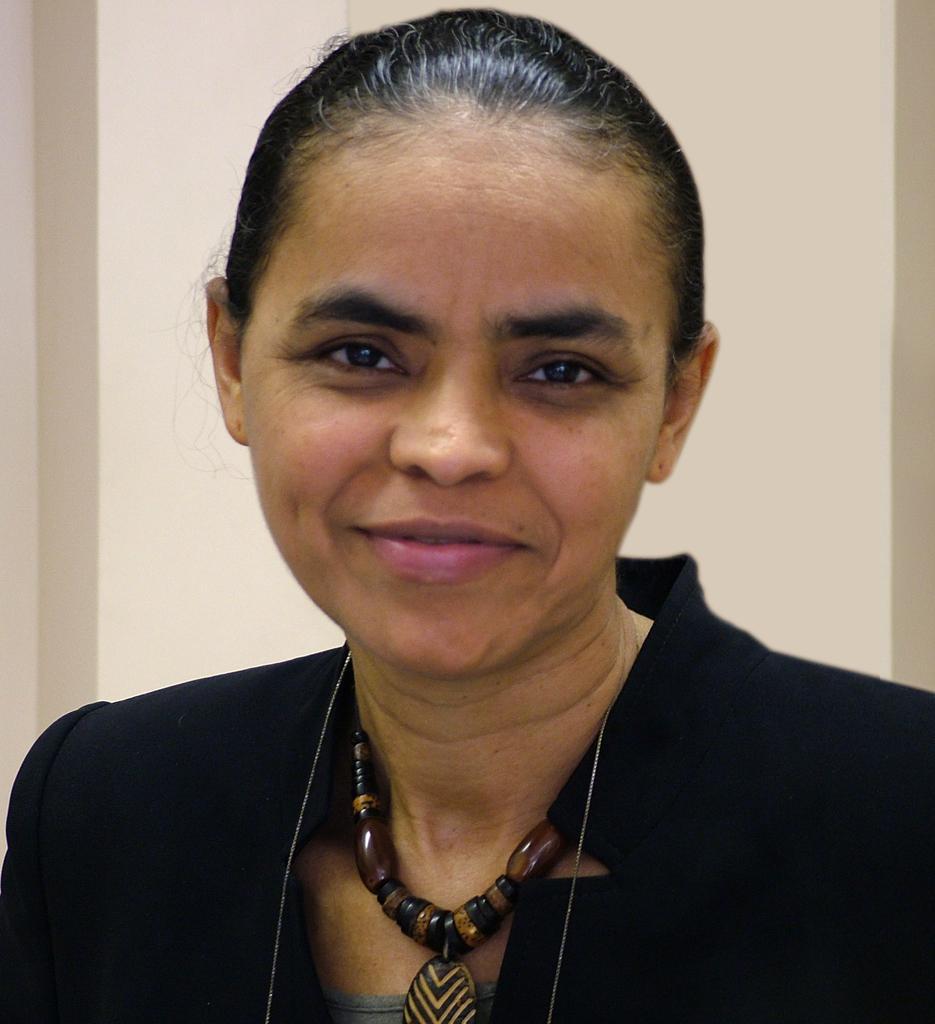Can you describe this image briefly? Background portion of the picture is in cream color. In this picture we can see a woman, wearing a chain around her neck and she is smiling. 